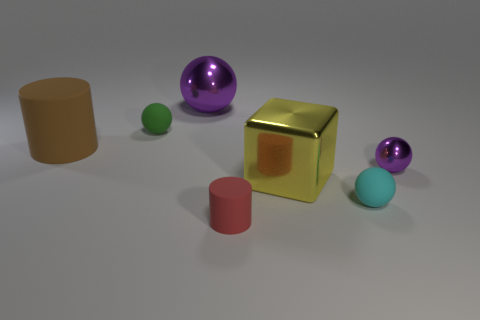The large brown thing that is the same material as the small cylinder is what shape?
Provide a short and direct response. Cylinder. Are there any other things of the same color as the large ball?
Offer a terse response. Yes. How many green matte things are on the right side of the matte cylinder right of the tiny rubber sphere behind the big block?
Give a very brief answer. 0. What number of brown things are either metallic objects or matte things?
Your answer should be compact. 1. There is a cyan matte ball; is it the same size as the purple metal object in front of the big matte cylinder?
Provide a succinct answer. Yes. There is a green object that is the same shape as the cyan rubber object; what is it made of?
Provide a succinct answer. Rubber. What number of other objects are there of the same size as the cyan ball?
Provide a short and direct response. 3. There is a big thing on the right side of the metal object behind the sphere right of the cyan ball; what is its shape?
Your answer should be very brief. Cube. There is a metallic object that is both to the right of the red matte cylinder and behind the yellow metal object; what is its shape?
Offer a terse response. Sphere. How many things are red objects or metallic balls on the left side of the cyan sphere?
Your response must be concise. 2. 